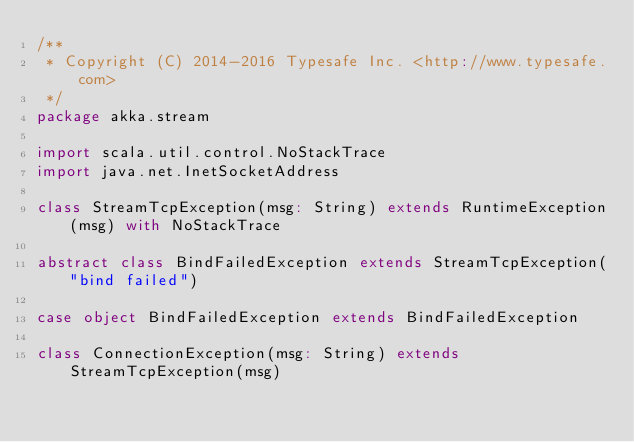<code> <loc_0><loc_0><loc_500><loc_500><_Scala_>/**
 * Copyright (C) 2014-2016 Typesafe Inc. <http://www.typesafe.com>
 */
package akka.stream

import scala.util.control.NoStackTrace
import java.net.InetSocketAddress

class StreamTcpException(msg: String) extends RuntimeException(msg) with NoStackTrace

abstract class BindFailedException extends StreamTcpException("bind failed")

case object BindFailedException extends BindFailedException

class ConnectionException(msg: String) extends StreamTcpException(msg)

</code> 